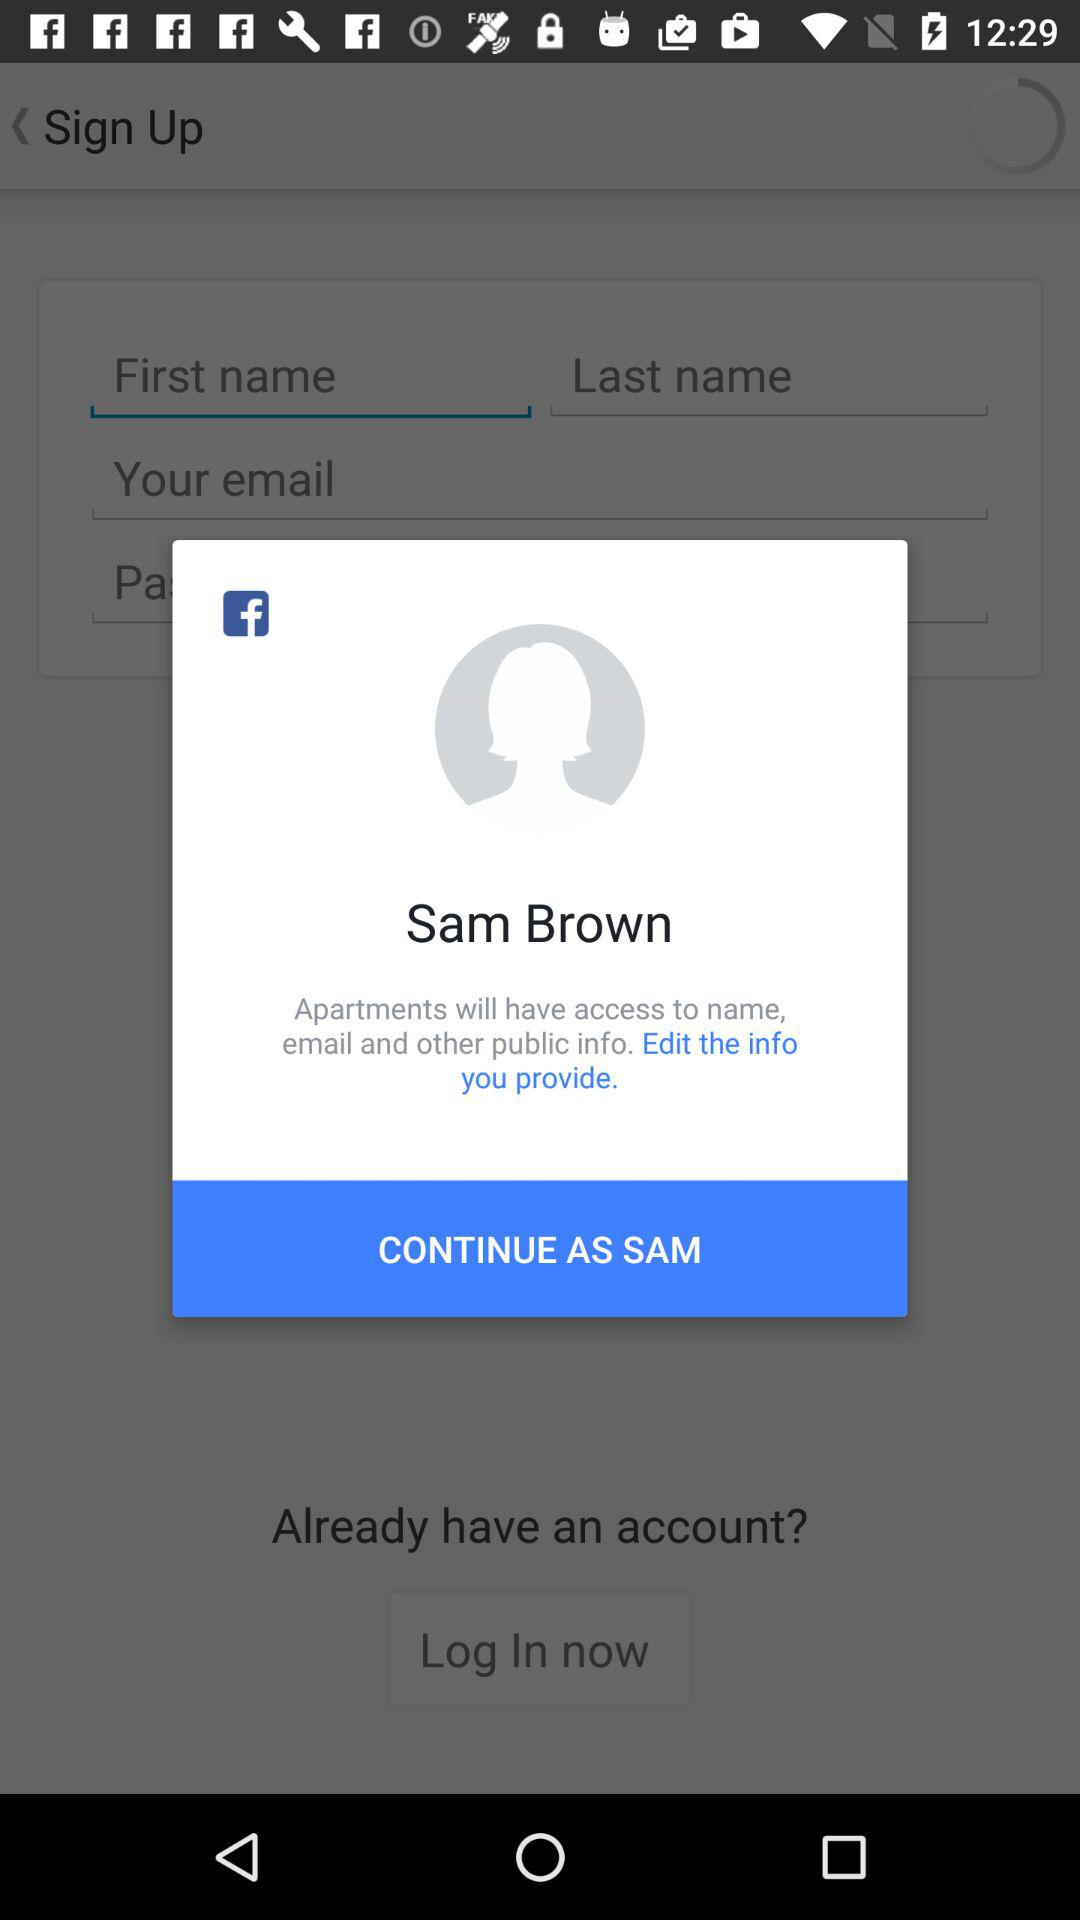What's the user profile name? The user profile name is Sam Brown. 